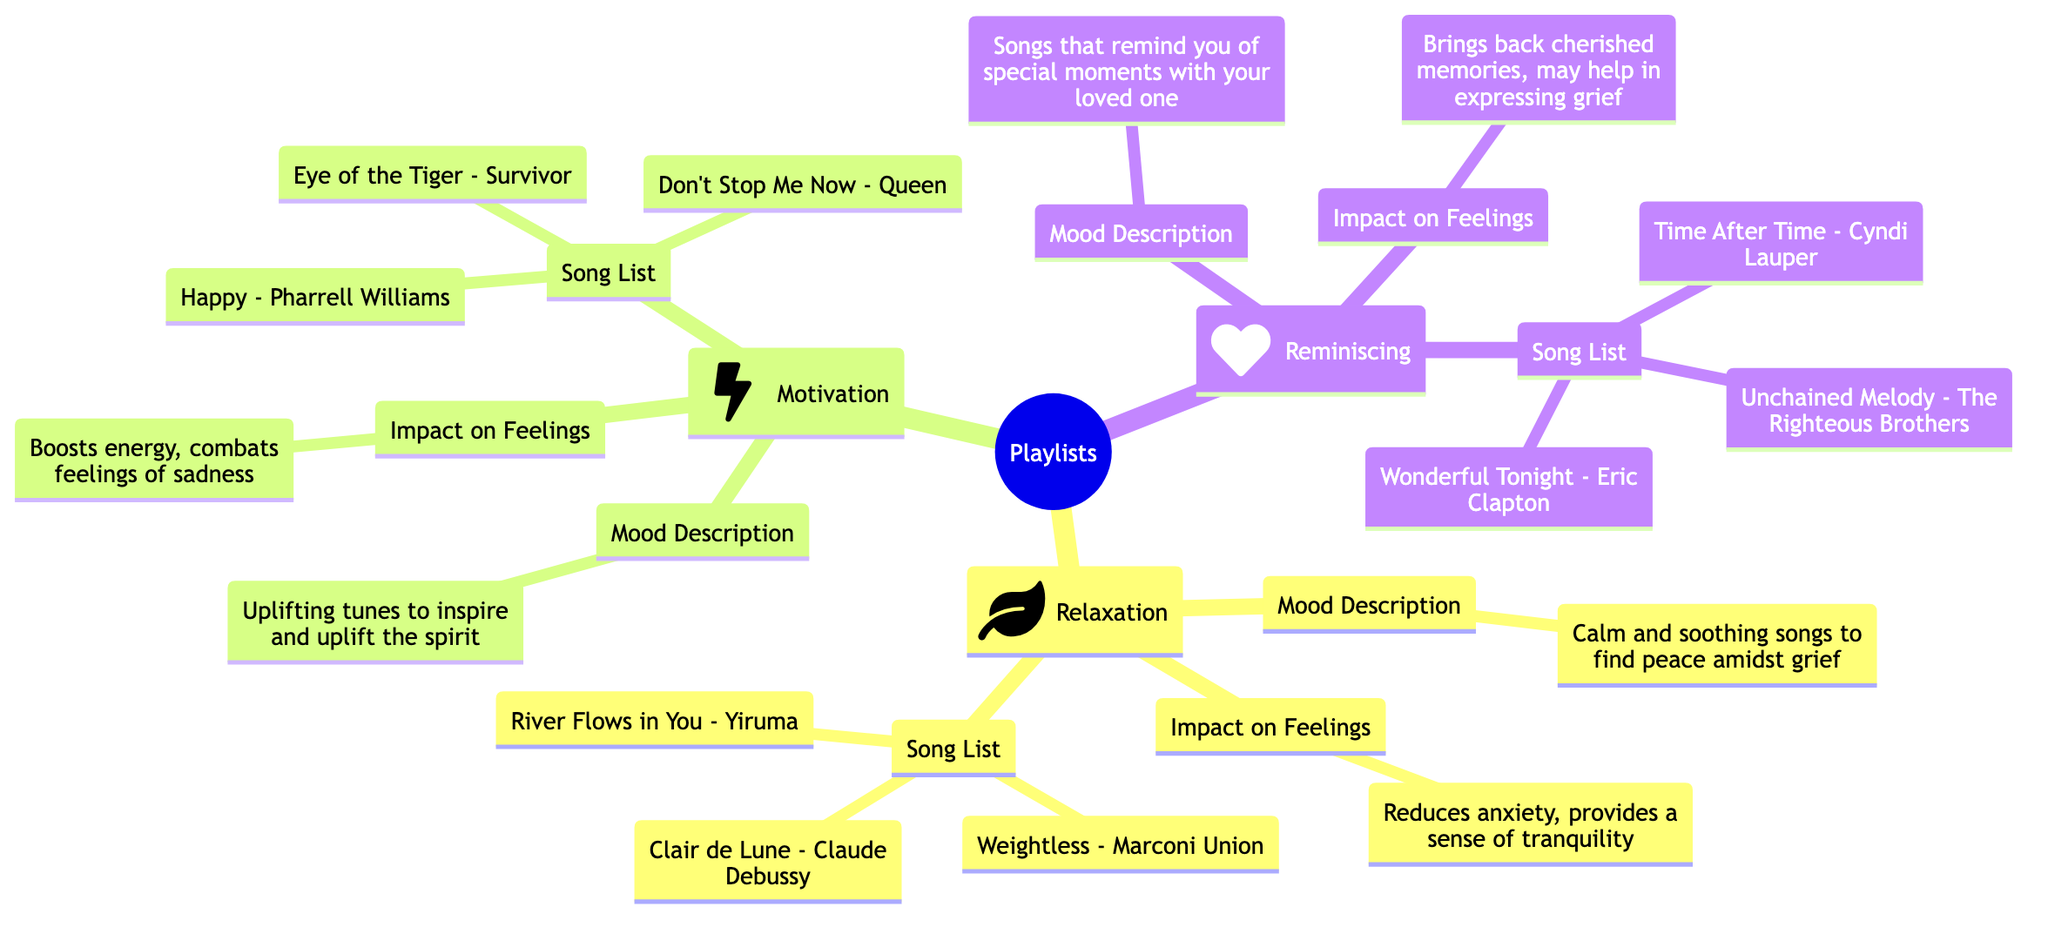What are the three emotional needs represented in the playlists? The central node 'Playlists' has three branches: 'Relaxation', 'Motivation', and 'Reminiscing'.
Answer: Relaxation, Motivation, Reminiscing What is the mood description for the 'Motivation' playlist? By looking at the 'Motivation' branch, the mood description is directly stated as "Uplifting tunes to inspire and uplift the spirit."
Answer: Uplifting tunes to inspire and uplift the spirit How many songs are listed under the 'Relaxation' playlist? The 'Relaxation' branch contains a 'Song List' and enumerates three songs, which can be counted directly.
Answer: 3 What is the impact on feelings described for the 'Reminiscing' playlist? The 'Reminiscing' branch includes the 'Impact on Feelings' which clearly states "Brings back cherished memories, may help in expressing grief."
Answer: Brings back cherished memories, may help in expressing grief Which playlist might be best for reducing anxiety? Reviewing the branches, the 'Relaxation' playlist’s impact states it "Reduces anxiety, provides a sense of tranquility," indicating its suitability.
Answer: Relaxation What song is listed first in the 'Motivation' playlist? The 'Song List' under the 'Motivation' branch begins with "Eye of the Tiger - Survivor," which can be identified as the first entry.
Answer: Eye of the Tiger - Survivor What icon represents the 'Relaxation' playlist in the mind map? Each playlist branch has an associated icon, and the 'Relaxation' playlist is marked by the icon representing nature, which is a leaf.
Answer: Leaf What do the playlists collectively address? The central theme of the mind map highlights how different playlists can cater to various emotional needs, specifically focusing on relaxation, motivation, and reminiscing.
Answer: Emotional needs 